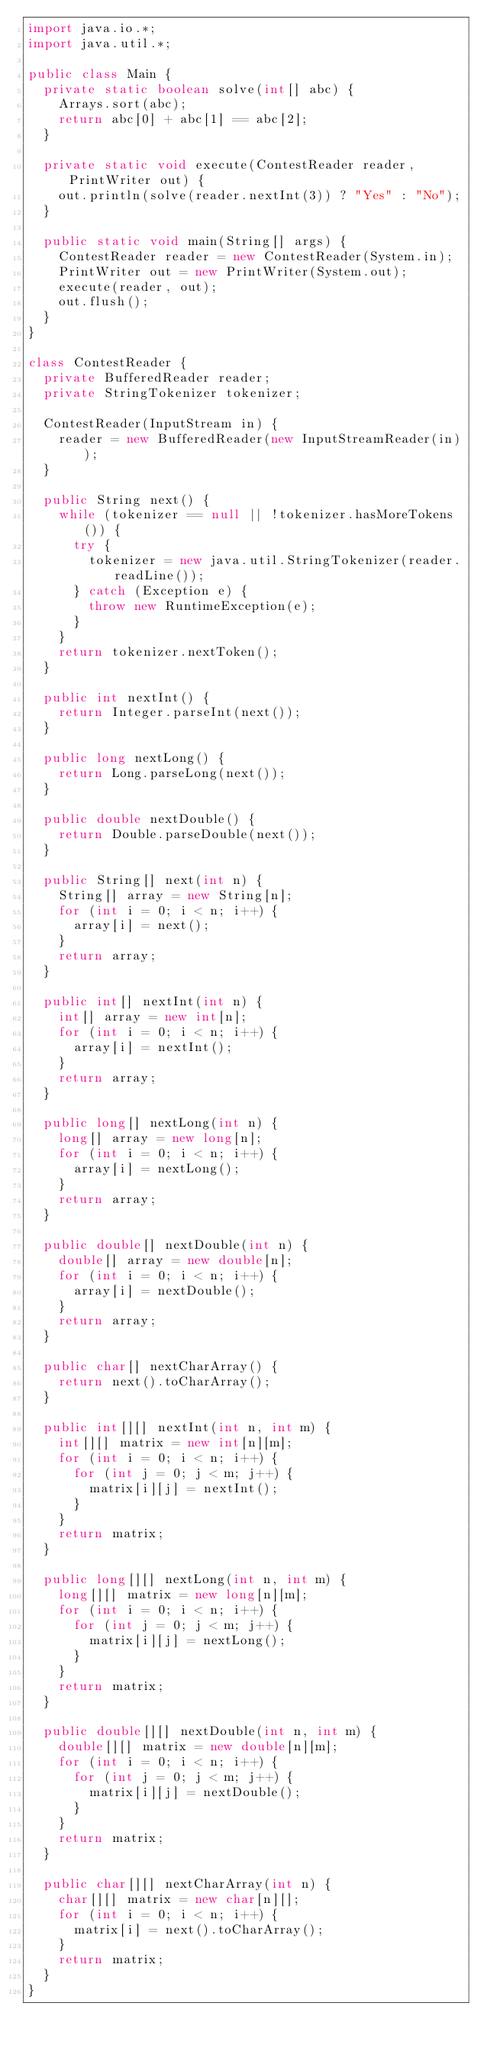<code> <loc_0><loc_0><loc_500><loc_500><_Java_>import java.io.*;
import java.util.*;

public class Main {
  private static boolean solve(int[] abc) {
    Arrays.sort(abc);
    return abc[0] + abc[1] == abc[2];
  }
  
  private static void execute(ContestReader reader, PrintWriter out) {
    out.println(solve(reader.nextInt(3)) ? "Yes" : "No");
  }
  
  public static void main(String[] args) {
    ContestReader reader = new ContestReader(System.in);
    PrintWriter out = new PrintWriter(System.out);
    execute(reader, out);
    out.flush();
  }
}

class ContestReader {
  private BufferedReader reader;
  private StringTokenizer tokenizer;
  
  ContestReader(InputStream in) {
    reader = new BufferedReader(new InputStreamReader(in));
  }
  
  public String next() {
    while (tokenizer == null || !tokenizer.hasMoreTokens()) {
      try {
        tokenizer = new java.util.StringTokenizer(reader.readLine());
      } catch (Exception e) {
        throw new RuntimeException(e);
      }
    }
    return tokenizer.nextToken();
  }
  
  public int nextInt() {
    return Integer.parseInt(next());
  }
  
  public long nextLong() {
    return Long.parseLong(next());
  }
  
  public double nextDouble() {
    return Double.parseDouble(next());
  }
  
  public String[] next(int n) {
    String[] array = new String[n];
    for (int i = 0; i < n; i++) {
      array[i] = next();
    }
    return array;
  }
  
  public int[] nextInt(int n) {
    int[] array = new int[n];
    for (int i = 0; i < n; i++) {
      array[i] = nextInt();
    }
    return array;
  }
  
  public long[] nextLong(int n) {
    long[] array = new long[n];
    for (int i = 0; i < n; i++) {
      array[i] = nextLong();
    }
    return array;
  }
  
  public double[] nextDouble(int n) {
    double[] array = new double[n];
    for (int i = 0; i < n; i++) {
      array[i] = nextDouble();
    }
    return array;
  }
  
  public char[] nextCharArray() {
    return next().toCharArray();
  }
  
  public int[][] nextInt(int n, int m) {
    int[][] matrix = new int[n][m];
    for (int i = 0; i < n; i++) {
      for (int j = 0; j < m; j++) {
        matrix[i][j] = nextInt();
      }
    }
    return matrix;
  }
  
  public long[][] nextLong(int n, int m) {
    long[][] matrix = new long[n][m];
    for (int i = 0; i < n; i++) {
      for (int j = 0; j < m; j++) {
        matrix[i][j] = nextLong();
      }
    }
    return matrix;
  }
  
  public double[][] nextDouble(int n, int m) {
    double[][] matrix = new double[n][m];
    for (int i = 0; i < n; i++) {
      for (int j = 0; j < m; j++) {
        matrix[i][j] = nextDouble();
      }
    }
    return matrix;
  }
  
  public char[][] nextCharArray(int n) {
    char[][] matrix = new char[n][];
    for (int i = 0; i < n; i++) {
      matrix[i] = next().toCharArray();
    }
    return matrix;
  }
}
</code> 